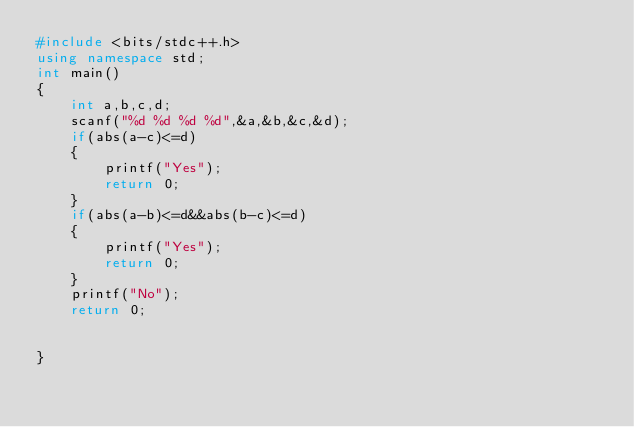<code> <loc_0><loc_0><loc_500><loc_500><_C++_>#include <bits/stdc++.h>
using namespace std;
int main() 
{
	int a,b,c,d;
	scanf("%d %d %d %d",&a,&b,&c,&d);
	if(abs(a-c)<=d)
	{
		printf("Yes");
		return 0;
	}
	if(abs(a-b)<=d&&abs(b-c)<=d)
	{
		printf("Yes");
		return 0;
	}
	printf("No");
	return 0;
	
	
}</code> 